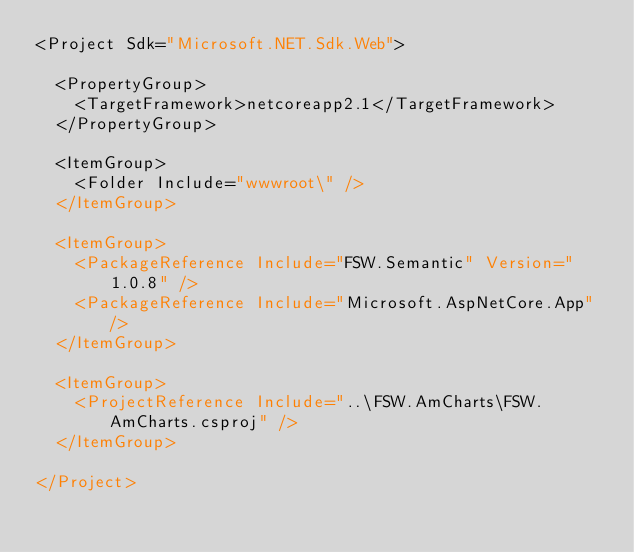Convert code to text. <code><loc_0><loc_0><loc_500><loc_500><_XML_><Project Sdk="Microsoft.NET.Sdk.Web">

  <PropertyGroup>
    <TargetFramework>netcoreapp2.1</TargetFramework>
  </PropertyGroup>

  <ItemGroup>
    <Folder Include="wwwroot\" />
  </ItemGroup>

  <ItemGroup>
    <PackageReference Include="FSW.Semantic" Version="1.0.8" />
    <PackageReference Include="Microsoft.AspNetCore.App" />
  </ItemGroup>

  <ItemGroup>
    <ProjectReference Include="..\FSW.AmCharts\FSW.AmCharts.csproj" />
  </ItemGroup>

</Project>
</code> 